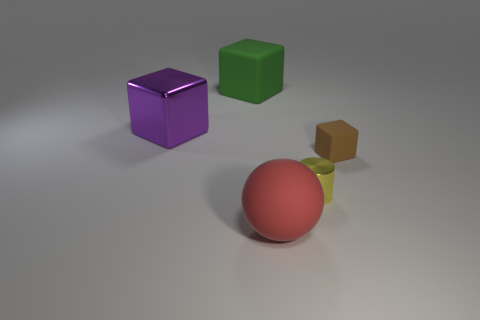What number of objects are yellow metal objects or matte things?
Your answer should be very brief. 4. The shiny object that is in front of the rubber object that is to the right of the thing that is in front of the cylinder is what shape?
Your response must be concise. Cylinder. Does the small thing that is on the right side of the small yellow thing have the same material as the big block that is in front of the large green block?
Your answer should be very brief. No. There is a big purple thing that is the same shape as the brown object; what is it made of?
Offer a terse response. Metal. Is the shape of the object behind the purple cube the same as the big purple thing behind the big red matte ball?
Make the answer very short. Yes. Is the number of green things in front of the large purple object less than the number of big spheres that are in front of the small matte cube?
Your answer should be compact. Yes. How many other objects are the same shape as the brown rubber object?
Give a very brief answer. 2. There is a big red object that is made of the same material as the green cube; what is its shape?
Ensure brevity in your answer.  Sphere. What color is the object that is to the left of the small yellow object and in front of the small matte thing?
Ensure brevity in your answer.  Red. Is the big cube on the left side of the big green matte cube made of the same material as the cylinder?
Provide a succinct answer. Yes. 